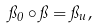<formula> <loc_0><loc_0><loc_500><loc_500>\pi _ { 0 } \circ \pi = \pi _ { u } ,</formula> 